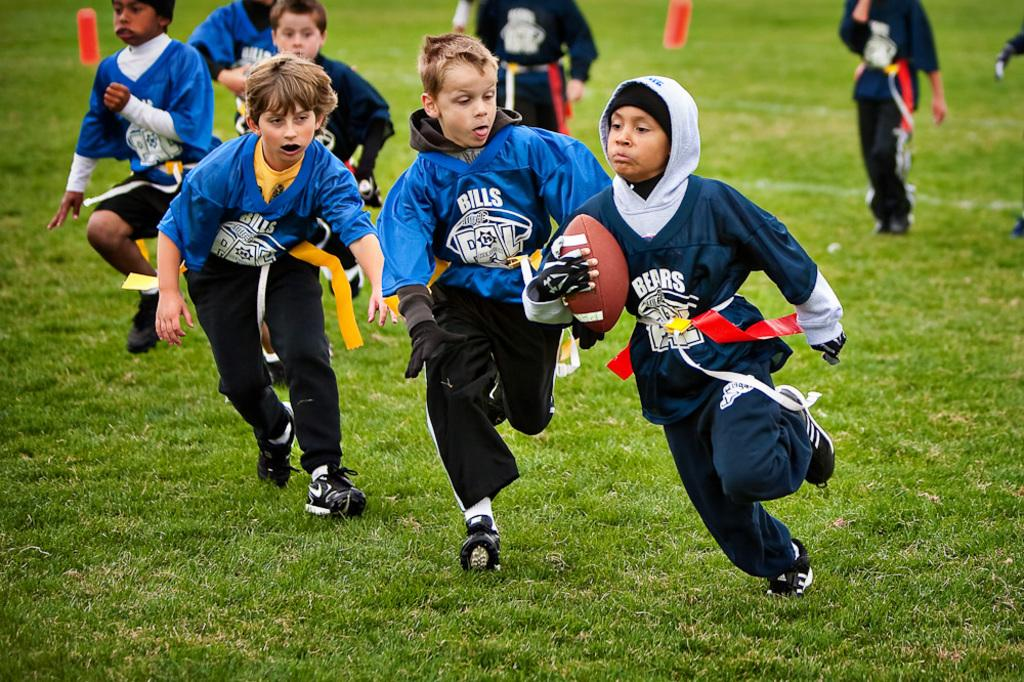What is the main subject of the image? The main subject of the image is a group of boys. What is one boy holding in his hand? One boy is holding a ball in his hand. What are some of the boys doing in the image? Some boys are running on the ground, while others are standing. What type of art can be seen hanging on the wall behind the boys? There is no art visible in the image; it only shows a group of boys, some running and others standing. 